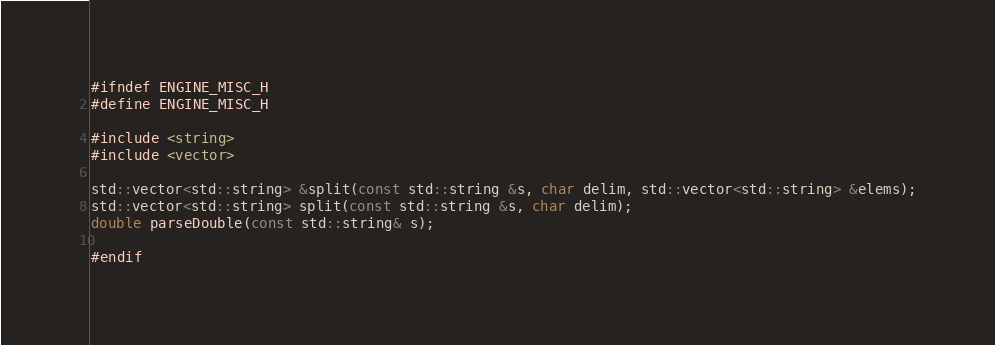Convert code to text. <code><loc_0><loc_0><loc_500><loc_500><_C_>#ifndef ENGINE_MISC_H
#define ENGINE_MISC_H

#include <string>
#include <vector>

std::vector<std::string> &split(const std::string &s, char delim, std::vector<std::string> &elems);
std::vector<std::string> split(const std::string &s, char delim);
double parseDouble(const std::string& s);

#endif
</code> 